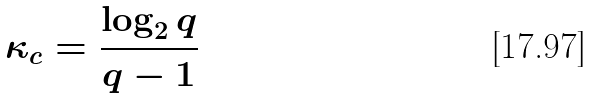Convert formula to latex. <formula><loc_0><loc_0><loc_500><loc_500>\kappa _ { c } = \frac { \log _ { 2 } q } { q - 1 }</formula> 